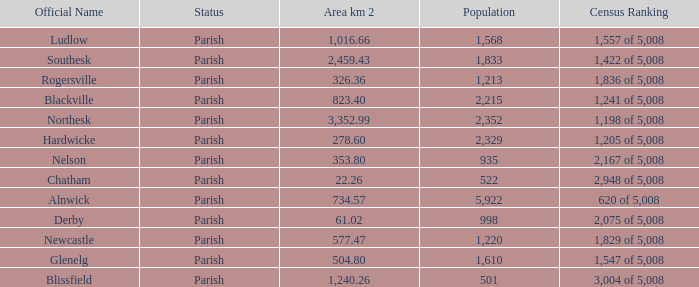Can you tell me the sum of Area km 2 that has the Official Name of glenelg? 504.8. 